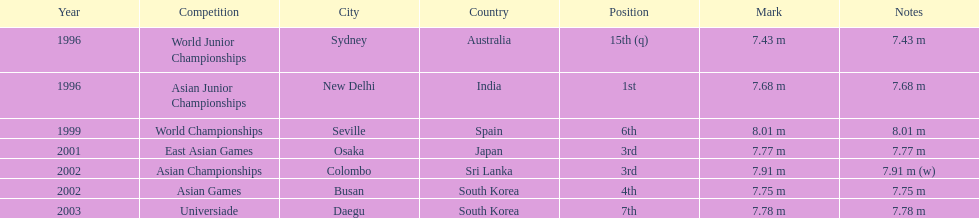What jumps did huang le make in 2002? 7.91 m (w), 7.75 m. Which jump was the longest? 7.91 m (w). 